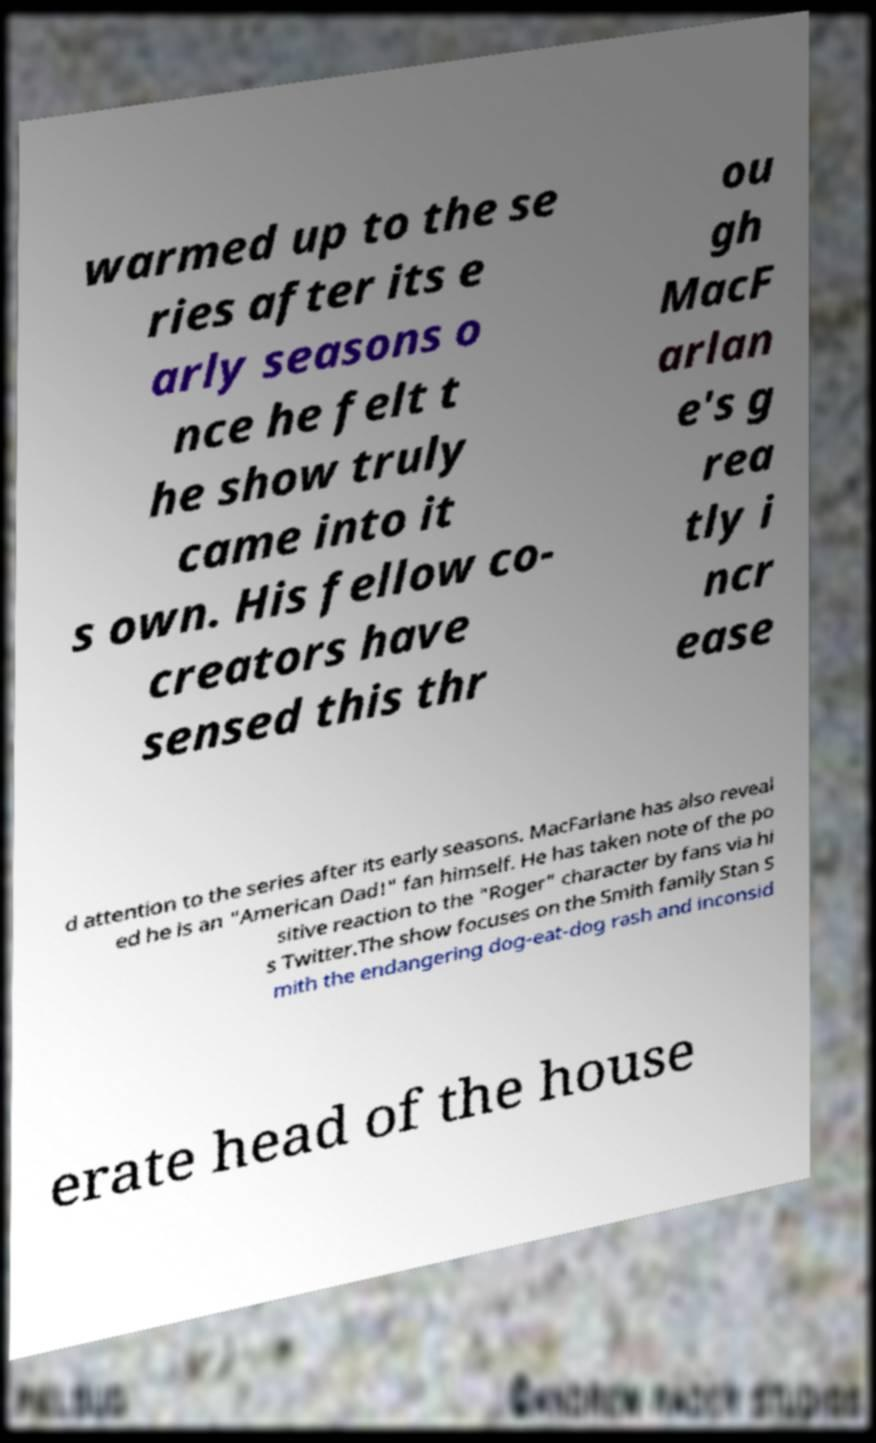Can you accurately transcribe the text from the provided image for me? warmed up to the se ries after its e arly seasons o nce he felt t he show truly came into it s own. His fellow co- creators have sensed this thr ou gh MacF arlan e's g rea tly i ncr ease d attention to the series after its early seasons. MacFarlane has also reveal ed he is an "American Dad!" fan himself. He has taken note of the po sitive reaction to the "Roger" character by fans via hi s Twitter.The show focuses on the Smith family Stan S mith the endangering dog-eat-dog rash and inconsid erate head of the house 